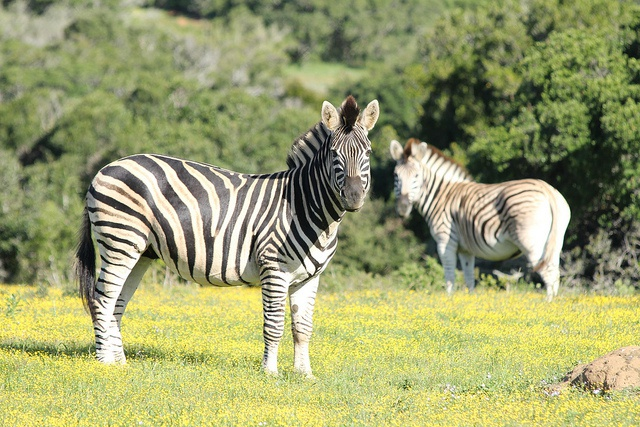Describe the objects in this image and their specific colors. I can see zebra in gray, ivory, black, and darkgray tones and zebra in gray, ivory, darkgray, and tan tones in this image. 